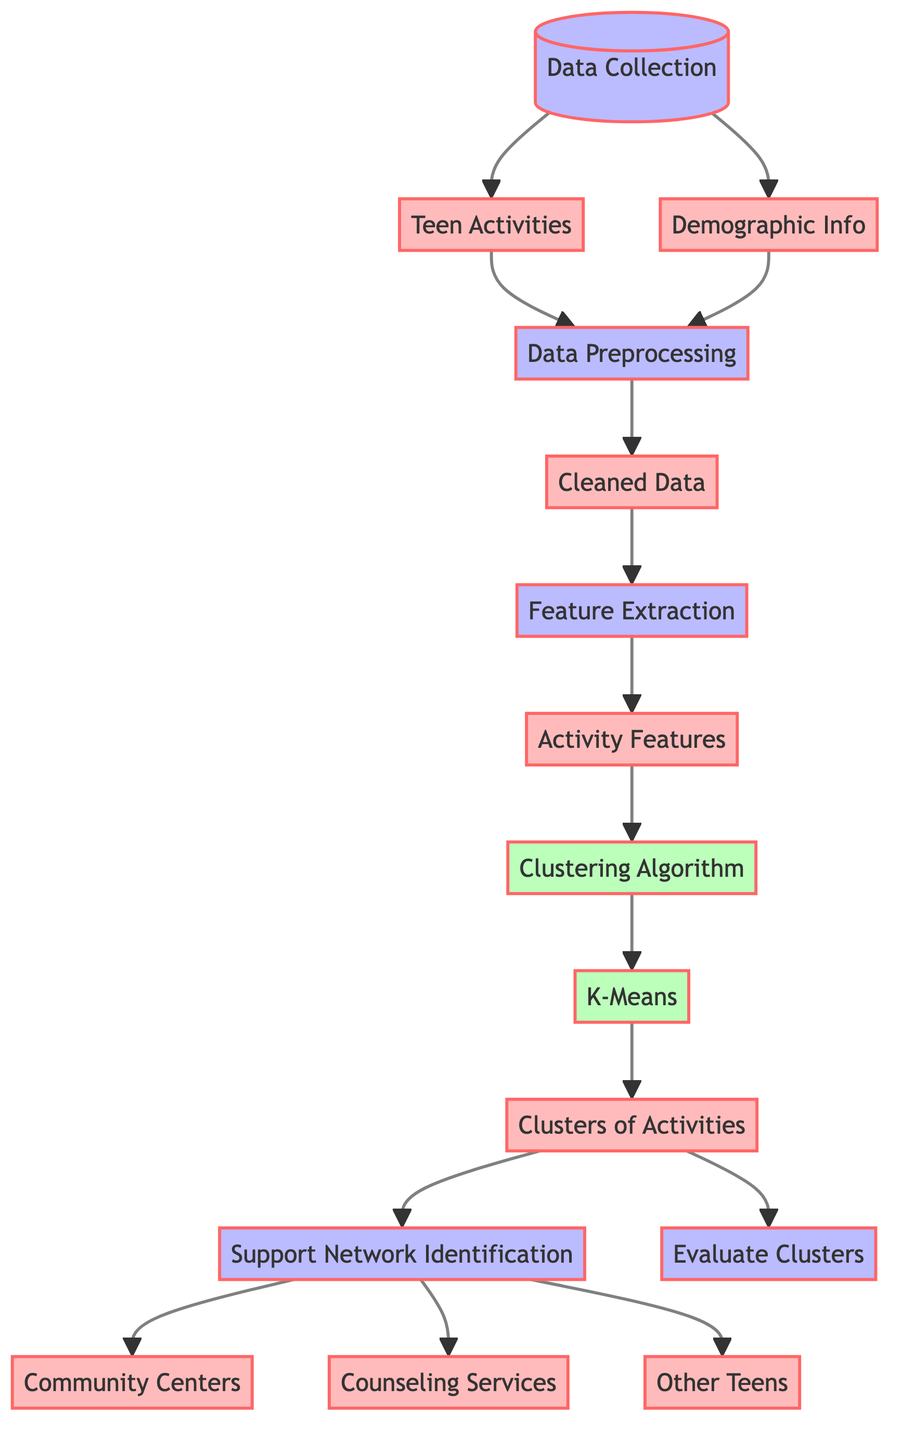What is the first step in the diagram? The first step in the diagram is "Data Collection," which starts the flow.
Answer: Data Collection How many kinds of data are collected? Two types of data are indicated: "Teen Activities" and "Demographic Info."
Answer: Two What algorithm is used for clustering? The diagram specifies the "K-Means" algorithm as the method for clustering the activities.
Answer: K-Means What is produced after the clustering algorithm is applied? After applying the clustering algorithm, the outcome is "Clusters of Activities," indicating the results of the clustering process.
Answer: Clusters of Activities Which supporting networks are identified in the process? The support network identification step leads to three outputs: "Community Centers," "Counseling Services," and "Other Teens."
Answer: Community Centers, Counseling Services, Other Teens What process follows "Data Preprocessing"? After "Data Preprocessing," the next step is "Feature Extraction," where significant features are derived from the cleaned data.
Answer: Feature Extraction How many nodes are in the diagram? The diagram includes a total of twelve nodes related to different parts of the process.
Answer: Twelve What is the purpose of the "Evaluate Clusters" step? This step allows for assessing the effectiveness and quality of the formed clusters after the clustering algorithm has been applied.
Answer: Evaluate Clusters How does demographic information relate to data preprocessing? The "Demographic Info" node feeds directly into the "Data Preprocessing" node, indicating that it is one of the essential components processed.
Answer: Directly feeds into Data Preprocessing What do the community centers represent in the output? "Community Centers" represent one type of support network identified for teens, aimed at providing resources and activities for engagement.
Answer: Support Network 